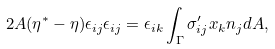Convert formula to latex. <formula><loc_0><loc_0><loc_500><loc_500>2 A ( \eta ^ { * } - \eta ) \epsilon _ { i j } \epsilon _ { i j } = \epsilon _ { i k } \int _ { \Gamma } \sigma ^ { \prime } _ { i j } x _ { k } n _ { j } d A ,</formula> 